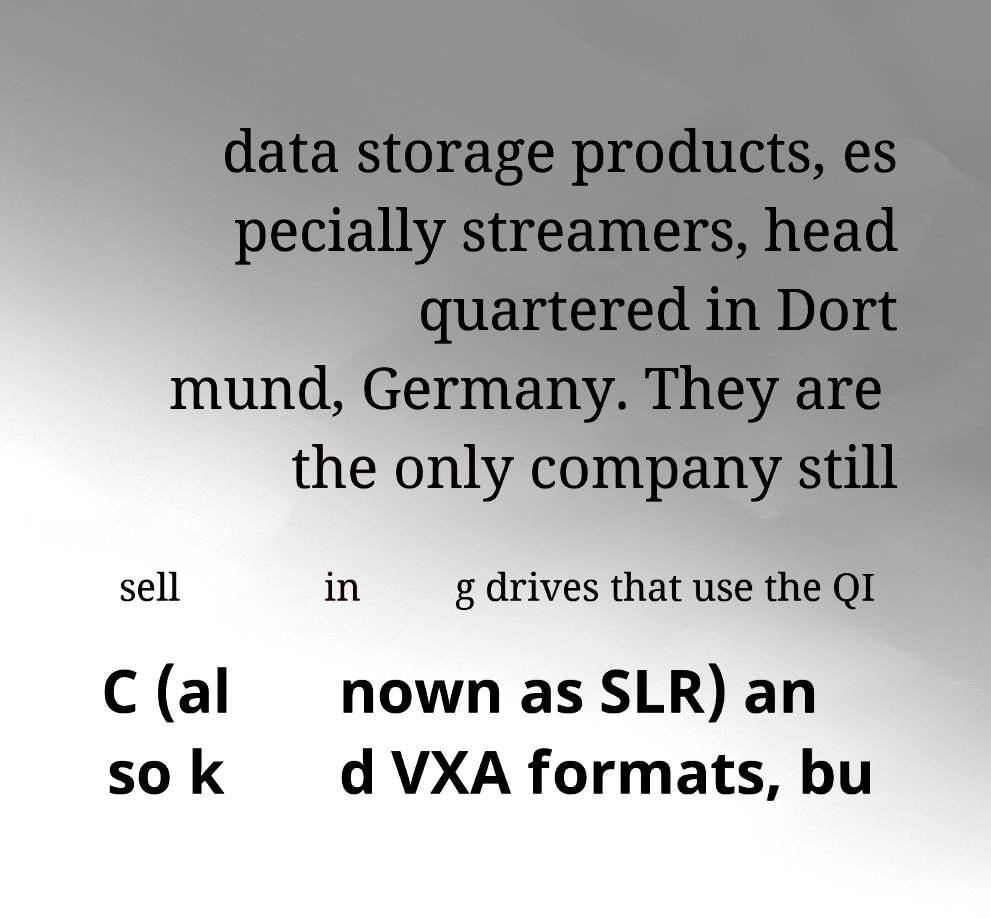What messages or text are displayed in this image? I need them in a readable, typed format. data storage products, es pecially streamers, head quartered in Dort mund, Germany. They are the only company still sell in g drives that use the QI C (al so k nown as SLR) an d VXA formats, bu 